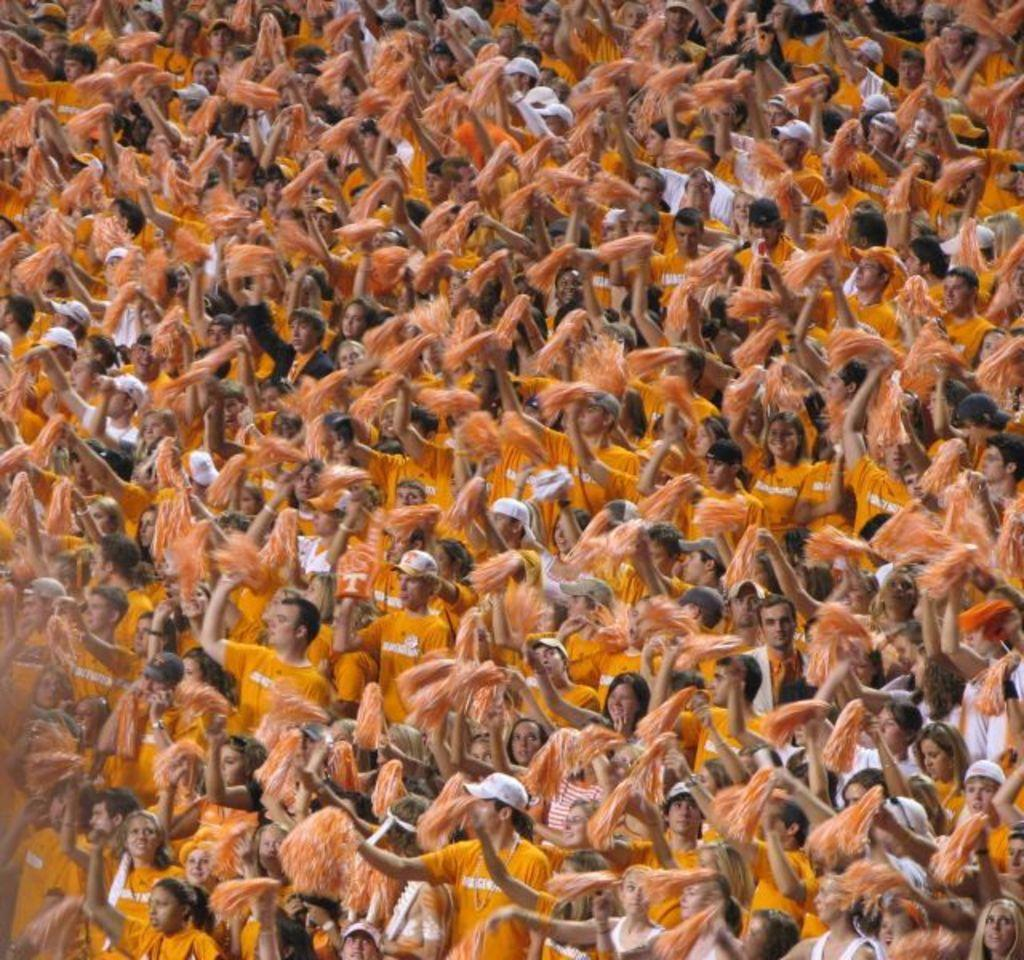How many individuals are present in the image? There are many people in the image. What type of headwear can be seen on some of the individuals? Some people are wearing caps in the image. What are some people holding in their hands? Some people are holding something in their hands in the image. What type of precipitation can be seen falling in the image? There is no precipitation visible in the image. How does the breath of the people appear in the image? There is no visible breath of the people in the image. 